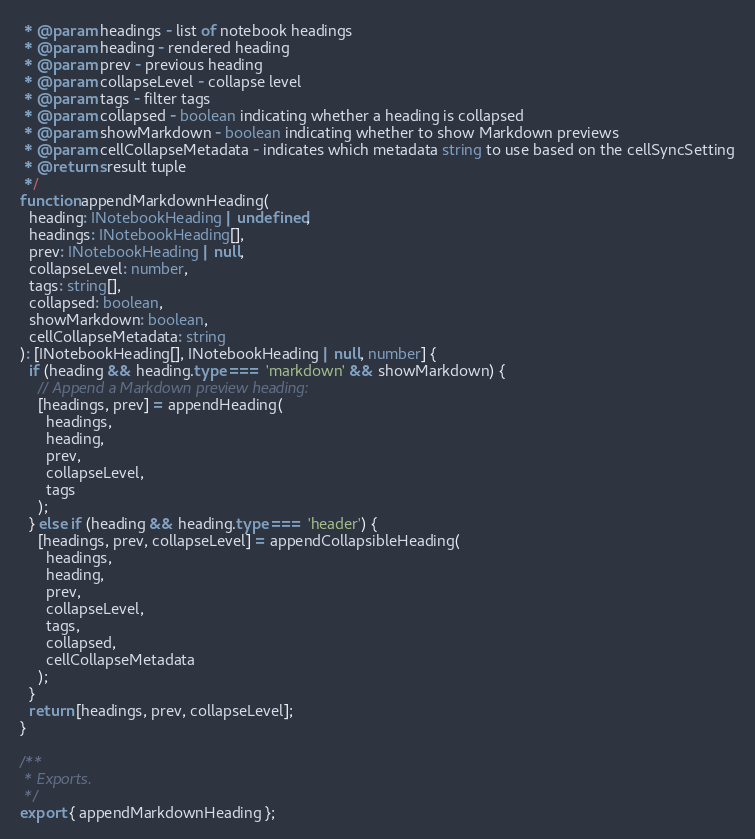Convert code to text. <code><loc_0><loc_0><loc_500><loc_500><_TypeScript_> * @param headings - list of notebook headings
 * @param heading - rendered heading
 * @param prev - previous heading
 * @param collapseLevel - collapse level
 * @param tags - filter tags
 * @param collapsed - boolean indicating whether a heading is collapsed
 * @param showMarkdown - boolean indicating whether to show Markdown previews
 * @param cellCollapseMetadata - indicates which metadata string to use based on the cellSyncSetting
 * @returns result tuple
 */
function appendMarkdownHeading(
  heading: INotebookHeading | undefined,
  headings: INotebookHeading[],
  prev: INotebookHeading | null,
  collapseLevel: number,
  tags: string[],
  collapsed: boolean,
  showMarkdown: boolean,
  cellCollapseMetadata: string
): [INotebookHeading[], INotebookHeading | null, number] {
  if (heading && heading.type === 'markdown' && showMarkdown) {
    // Append a Markdown preview heading:
    [headings, prev] = appendHeading(
      headings,
      heading,
      prev,
      collapseLevel,
      tags
    );
  } else if (heading && heading.type === 'header') {
    [headings, prev, collapseLevel] = appendCollapsibleHeading(
      headings,
      heading,
      prev,
      collapseLevel,
      tags,
      collapsed,
      cellCollapseMetadata
    );
  }
  return [headings, prev, collapseLevel];
}

/**
 * Exports.
 */
export { appendMarkdownHeading };
</code> 